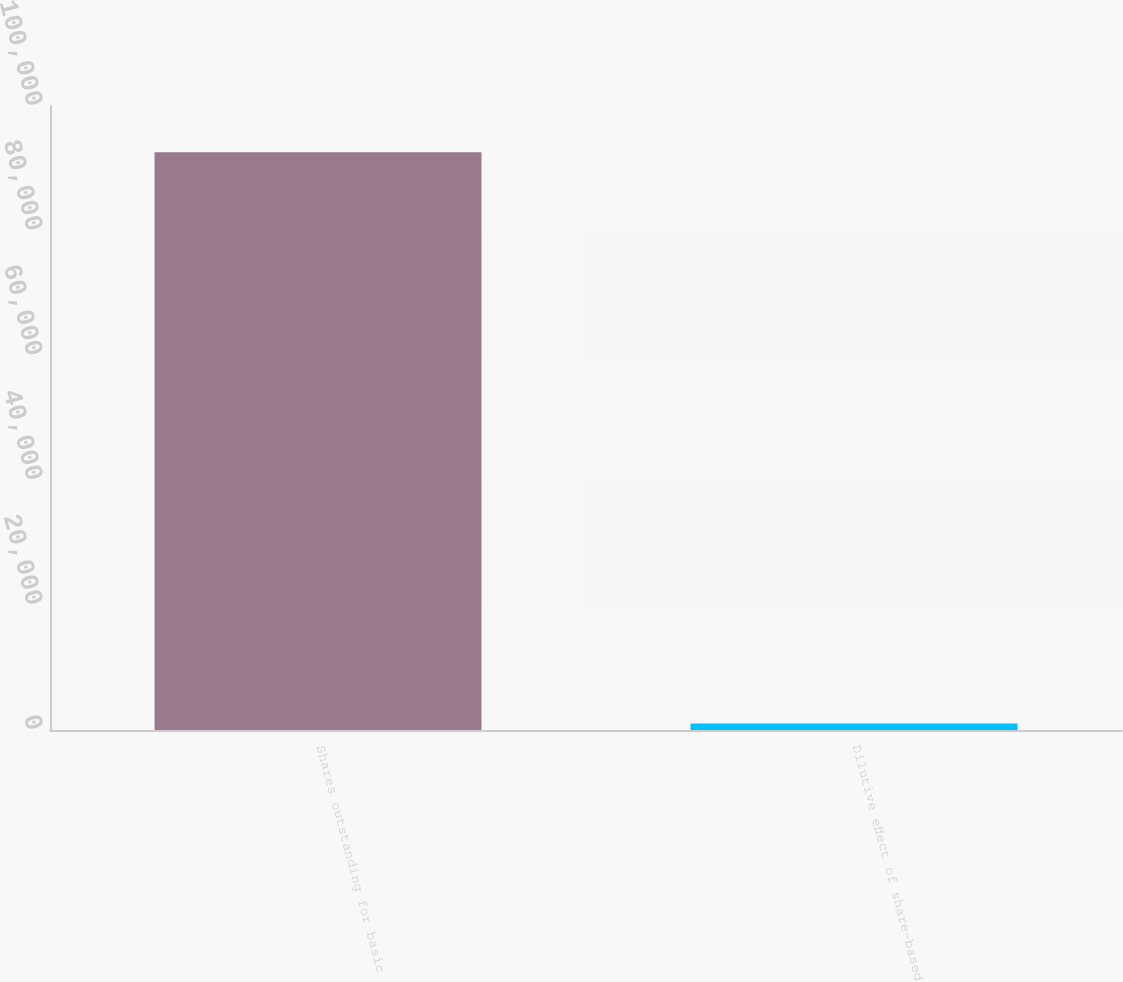Convert chart. <chart><loc_0><loc_0><loc_500><loc_500><bar_chart><fcel>Shares outstanding for basic<fcel>Dilutive effect of share-based<nl><fcel>92601<fcel>1048<nl></chart> 